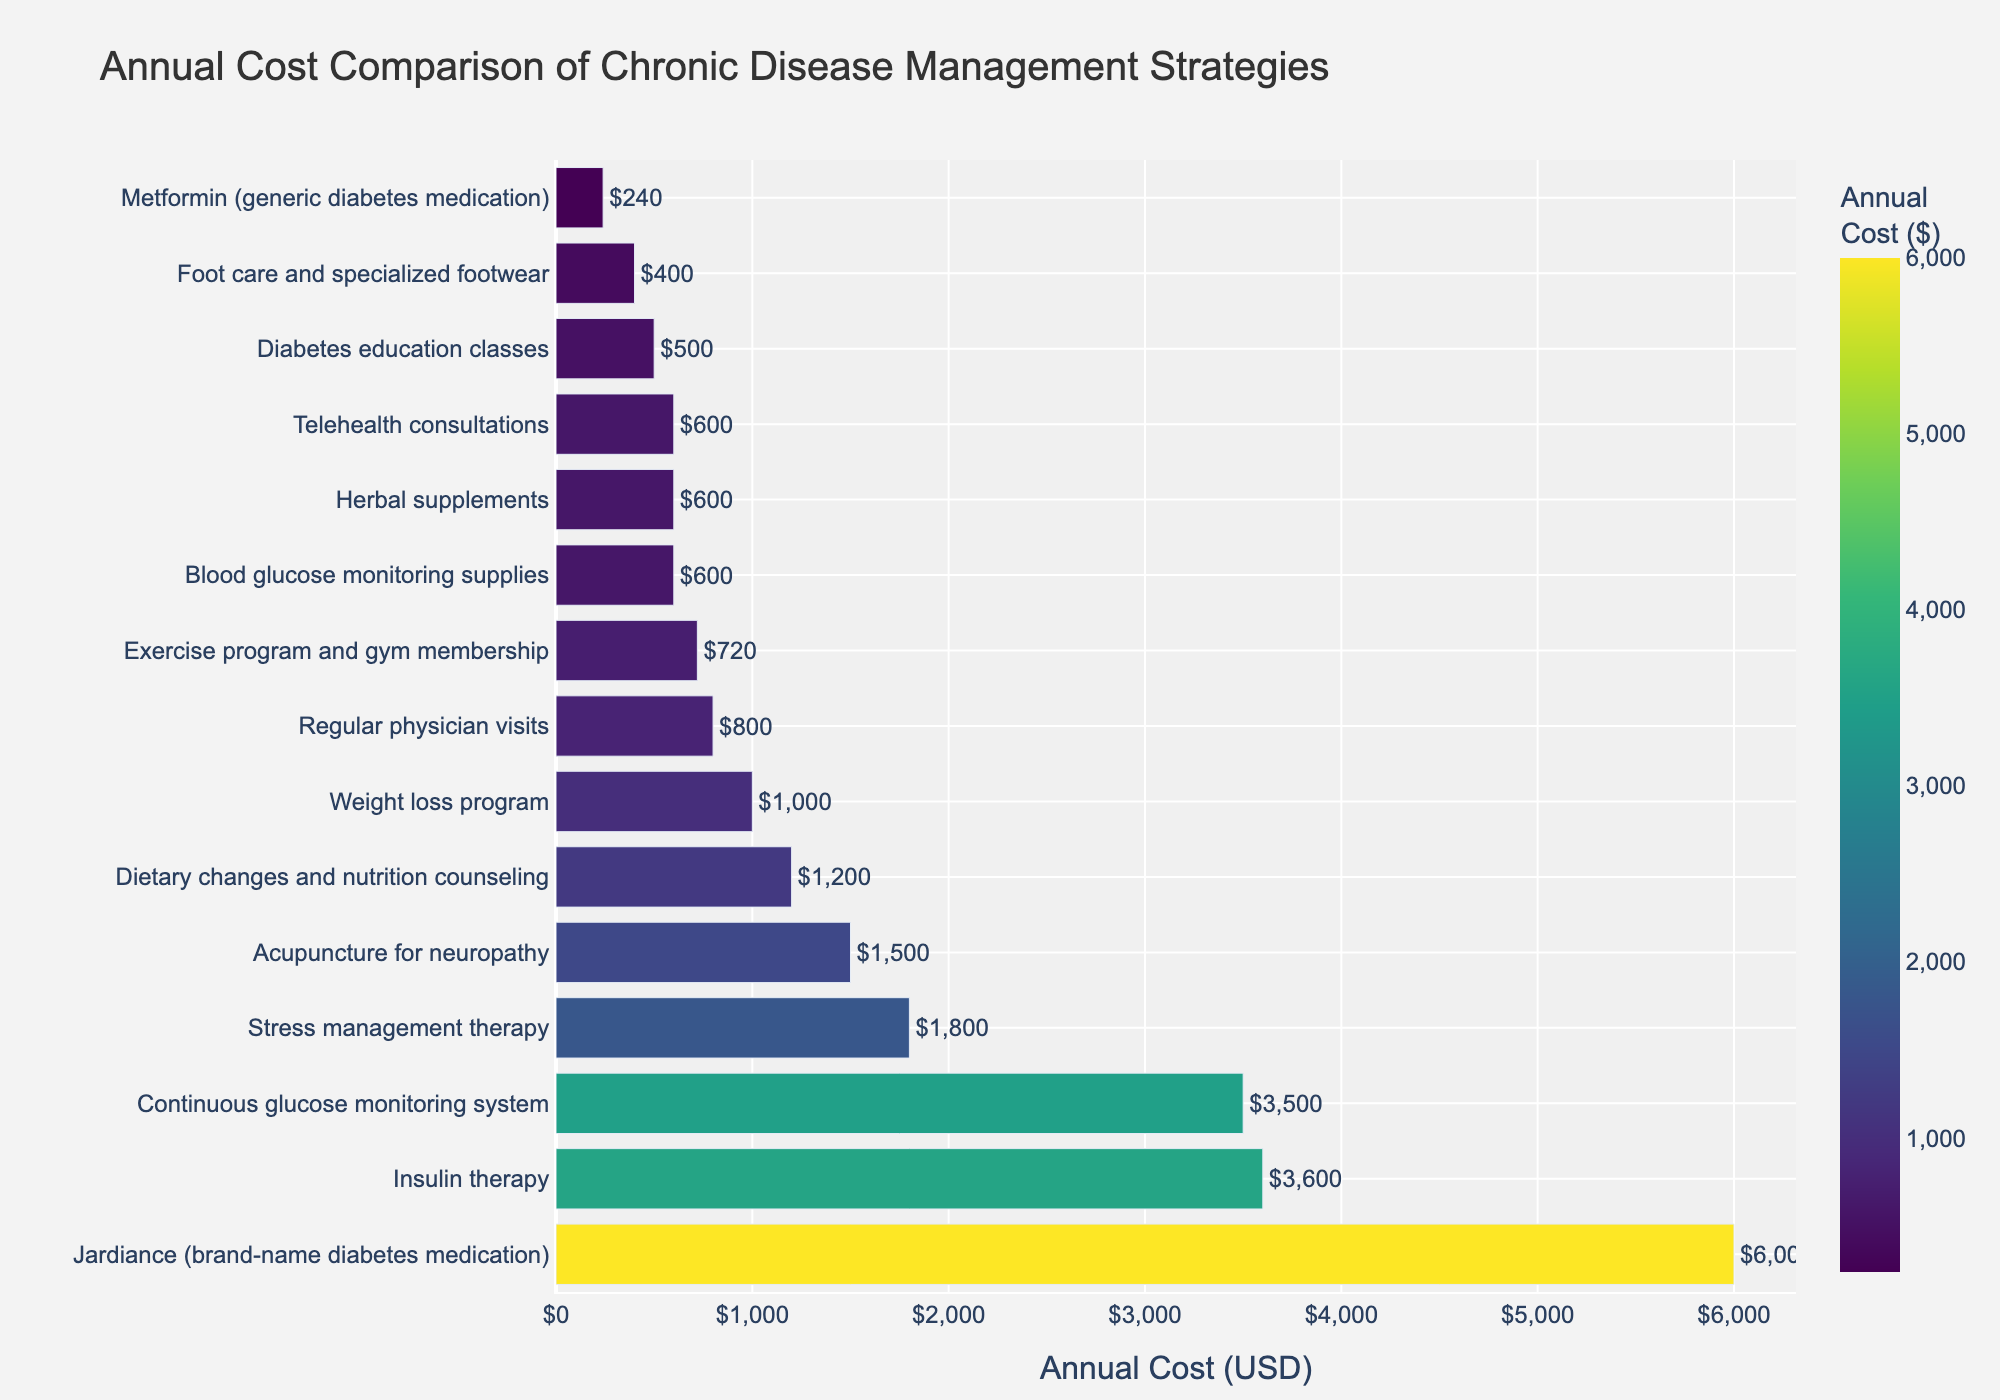what is the most expensive chronic disease management strategy? The longest bar in the figure represents the most expensive strategy. In this case, "Jardiance (brand-name diabetes medication)" has the highest annual cost at $6000.
Answer: Jardiance What is the total annual cost of "Continuous glucose monitoring system" and "Insulin therapy"? According to the figure, the annual cost for "Continuous glucose monitoring system" is $3500, and for "Insulin therapy," it is $3600. Summing these two values gives $3500 + $3600 = $7100.
Answer: $7100 Which strategy has a lower annual cost: "Regular physician visits" or "Telehealth consultations"? By comparing the length of the bars, "Telehealth consultations" show an annual cost of $600, while "Regular physician visits" cost $800 annually. Therefore, "Telehealth consultations" is less expensive.
Answer: Telehealth consultations What is the difference in annual costs between "Stress management therapy" and "Weight loss program"? The annual cost of "Stress management therapy" is $1800, and the cost of "Weight loss program" is $1000. The difference is calculated as $1800 - $1000 = $800.
Answer: $800 How many strategies have an annual cost below $1000? In the figure, the strategies that cost below $1000 are: "Metformin (generic diabetes medication)" ($240), "Regular physician visits" ($800), "Blood glucose monitoring supplies" ($600), "Diabetes education classes" ($500), "Foot care and specialized footwear" ($400), "Weight loss program" ($1000), "Herbal supplements" ($600), and "Telehealth consultations" ($600). There are 8 such strategies.
Answer: 8 Which strategy has a visually distinct cost that falls between "Acupuncture for neuropathy" and "Dietary changes and nutrition counseling"? "Acupuncture for neuropathy" costs $1500, while "Dietary changes and nutrition counseling" cost $1200. "Stress management therapy," which costs $1800, falls between them but remains visually distinct as it is higher than both on the chart.
Answer: Stress management therapy What is the median annual cost of all the strategies? To find the median, we must order the annual costs and select the middle value. The sorted costs are: $240, $400, $500, $600, $600, $720, $800, $1000, $1200, $1500, $1800, $3500, $3600, $6000. The middle value (7th value in a set of 15) is $800.
Answer: $800 